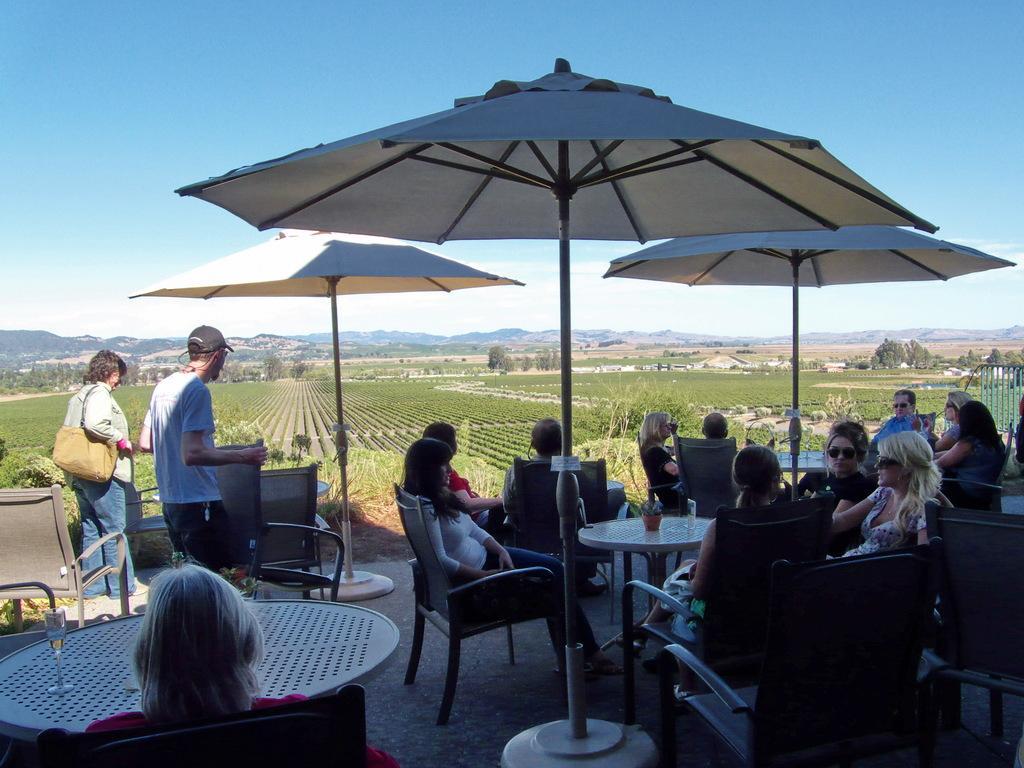How would you summarize this image in a sentence or two? This picture shows a group of people seated on the chairs and we see two people standing and we see few umbrellas and trees around 